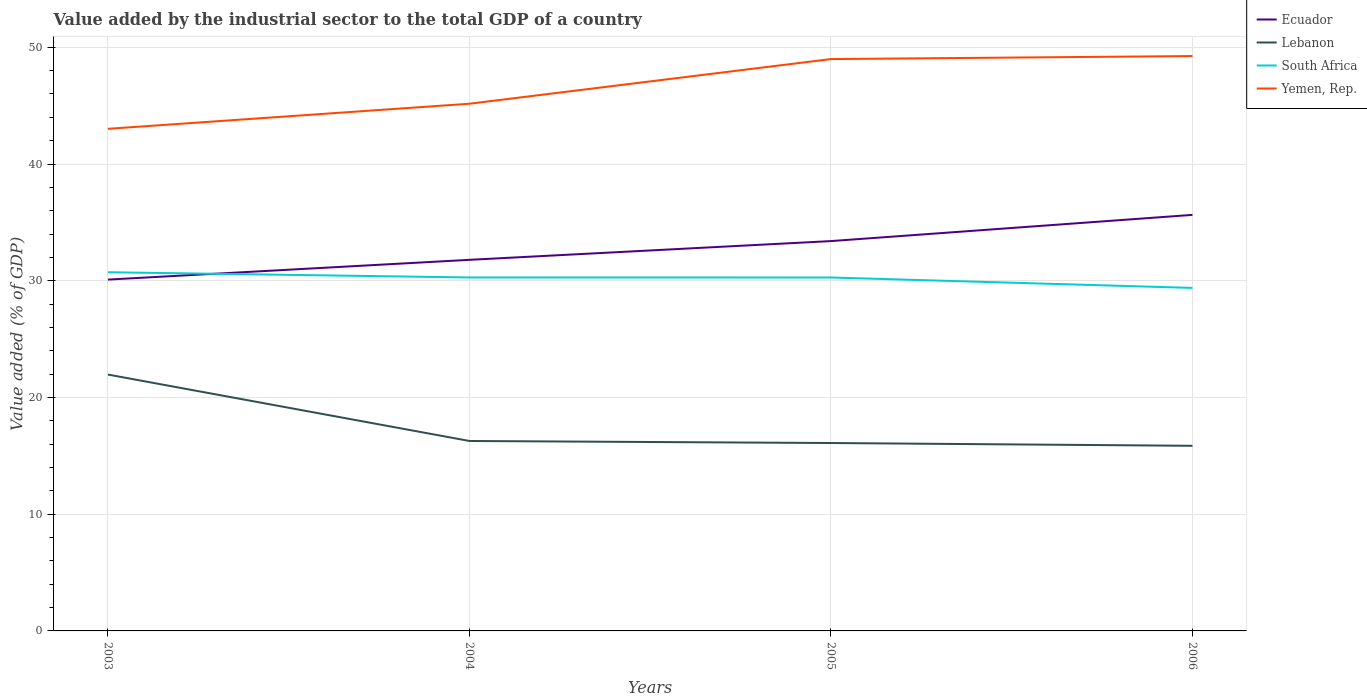How many different coloured lines are there?
Keep it short and to the point. 4. Is the number of lines equal to the number of legend labels?
Offer a very short reply. Yes. Across all years, what is the maximum value added by the industrial sector to the total GDP in Yemen, Rep.?
Ensure brevity in your answer.  43.01. What is the total value added by the industrial sector to the total GDP in Lebanon in the graph?
Your response must be concise. 5.69. What is the difference between the highest and the second highest value added by the industrial sector to the total GDP in Yemen, Rep.?
Provide a succinct answer. 6.23. What is the difference between the highest and the lowest value added by the industrial sector to the total GDP in South Africa?
Your answer should be very brief. 3. How many years are there in the graph?
Give a very brief answer. 4. What is the difference between two consecutive major ticks on the Y-axis?
Offer a very short reply. 10. Does the graph contain any zero values?
Give a very brief answer. No. How many legend labels are there?
Offer a very short reply. 4. What is the title of the graph?
Your answer should be compact. Value added by the industrial sector to the total GDP of a country. Does "World" appear as one of the legend labels in the graph?
Your response must be concise. No. What is the label or title of the X-axis?
Ensure brevity in your answer.  Years. What is the label or title of the Y-axis?
Provide a succinct answer. Value added (% of GDP). What is the Value added (% of GDP) of Ecuador in 2003?
Offer a terse response. 30.1. What is the Value added (% of GDP) of Lebanon in 2003?
Your answer should be compact. 21.96. What is the Value added (% of GDP) of South Africa in 2003?
Your answer should be very brief. 30.73. What is the Value added (% of GDP) of Yemen, Rep. in 2003?
Keep it short and to the point. 43.01. What is the Value added (% of GDP) in Ecuador in 2004?
Make the answer very short. 31.79. What is the Value added (% of GDP) of Lebanon in 2004?
Provide a short and direct response. 16.27. What is the Value added (% of GDP) of South Africa in 2004?
Your response must be concise. 30.28. What is the Value added (% of GDP) of Yemen, Rep. in 2004?
Provide a succinct answer. 45.16. What is the Value added (% of GDP) of Ecuador in 2005?
Ensure brevity in your answer.  33.4. What is the Value added (% of GDP) of Lebanon in 2005?
Ensure brevity in your answer.  16.1. What is the Value added (% of GDP) in South Africa in 2005?
Your answer should be very brief. 30.28. What is the Value added (% of GDP) in Yemen, Rep. in 2005?
Your answer should be compact. 48.99. What is the Value added (% of GDP) of Ecuador in 2006?
Give a very brief answer. 35.64. What is the Value added (% of GDP) of Lebanon in 2006?
Your response must be concise. 15.86. What is the Value added (% of GDP) of South Africa in 2006?
Your response must be concise. 29.39. What is the Value added (% of GDP) of Yemen, Rep. in 2006?
Provide a succinct answer. 49.25. Across all years, what is the maximum Value added (% of GDP) in Ecuador?
Make the answer very short. 35.64. Across all years, what is the maximum Value added (% of GDP) in Lebanon?
Offer a very short reply. 21.96. Across all years, what is the maximum Value added (% of GDP) of South Africa?
Make the answer very short. 30.73. Across all years, what is the maximum Value added (% of GDP) of Yemen, Rep.?
Your response must be concise. 49.25. Across all years, what is the minimum Value added (% of GDP) in Ecuador?
Provide a succinct answer. 30.1. Across all years, what is the minimum Value added (% of GDP) in Lebanon?
Provide a short and direct response. 15.86. Across all years, what is the minimum Value added (% of GDP) in South Africa?
Keep it short and to the point. 29.39. Across all years, what is the minimum Value added (% of GDP) of Yemen, Rep.?
Make the answer very short. 43.01. What is the total Value added (% of GDP) in Ecuador in the graph?
Provide a short and direct response. 130.93. What is the total Value added (% of GDP) of Lebanon in the graph?
Offer a very short reply. 70.19. What is the total Value added (% of GDP) of South Africa in the graph?
Make the answer very short. 120.67. What is the total Value added (% of GDP) in Yemen, Rep. in the graph?
Keep it short and to the point. 186.42. What is the difference between the Value added (% of GDP) in Ecuador in 2003 and that in 2004?
Your answer should be very brief. -1.69. What is the difference between the Value added (% of GDP) of Lebanon in 2003 and that in 2004?
Ensure brevity in your answer.  5.69. What is the difference between the Value added (% of GDP) of South Africa in 2003 and that in 2004?
Provide a short and direct response. 0.45. What is the difference between the Value added (% of GDP) of Yemen, Rep. in 2003 and that in 2004?
Your answer should be very brief. -2.15. What is the difference between the Value added (% of GDP) in Ecuador in 2003 and that in 2005?
Your response must be concise. -3.3. What is the difference between the Value added (% of GDP) in Lebanon in 2003 and that in 2005?
Ensure brevity in your answer.  5.87. What is the difference between the Value added (% of GDP) in South Africa in 2003 and that in 2005?
Your response must be concise. 0.45. What is the difference between the Value added (% of GDP) in Yemen, Rep. in 2003 and that in 2005?
Your answer should be very brief. -5.97. What is the difference between the Value added (% of GDP) of Ecuador in 2003 and that in 2006?
Your response must be concise. -5.54. What is the difference between the Value added (% of GDP) in Lebanon in 2003 and that in 2006?
Offer a very short reply. 6.1. What is the difference between the Value added (% of GDP) in South Africa in 2003 and that in 2006?
Make the answer very short. 1.34. What is the difference between the Value added (% of GDP) in Yemen, Rep. in 2003 and that in 2006?
Your answer should be compact. -6.23. What is the difference between the Value added (% of GDP) of Ecuador in 2004 and that in 2005?
Your response must be concise. -1.61. What is the difference between the Value added (% of GDP) of Lebanon in 2004 and that in 2005?
Offer a terse response. 0.17. What is the difference between the Value added (% of GDP) of South Africa in 2004 and that in 2005?
Keep it short and to the point. 0. What is the difference between the Value added (% of GDP) in Yemen, Rep. in 2004 and that in 2005?
Offer a terse response. -3.83. What is the difference between the Value added (% of GDP) of Ecuador in 2004 and that in 2006?
Provide a succinct answer. -3.85. What is the difference between the Value added (% of GDP) in Lebanon in 2004 and that in 2006?
Offer a terse response. 0.41. What is the difference between the Value added (% of GDP) of South Africa in 2004 and that in 2006?
Keep it short and to the point. 0.89. What is the difference between the Value added (% of GDP) in Yemen, Rep. in 2004 and that in 2006?
Make the answer very short. -4.08. What is the difference between the Value added (% of GDP) in Ecuador in 2005 and that in 2006?
Offer a very short reply. -2.25. What is the difference between the Value added (% of GDP) in Lebanon in 2005 and that in 2006?
Provide a short and direct response. 0.24. What is the difference between the Value added (% of GDP) in South Africa in 2005 and that in 2006?
Make the answer very short. 0.89. What is the difference between the Value added (% of GDP) in Yemen, Rep. in 2005 and that in 2006?
Provide a short and direct response. -0.26. What is the difference between the Value added (% of GDP) of Ecuador in 2003 and the Value added (% of GDP) of Lebanon in 2004?
Give a very brief answer. 13.83. What is the difference between the Value added (% of GDP) of Ecuador in 2003 and the Value added (% of GDP) of South Africa in 2004?
Keep it short and to the point. -0.18. What is the difference between the Value added (% of GDP) of Ecuador in 2003 and the Value added (% of GDP) of Yemen, Rep. in 2004?
Keep it short and to the point. -15.07. What is the difference between the Value added (% of GDP) in Lebanon in 2003 and the Value added (% of GDP) in South Africa in 2004?
Offer a terse response. -8.32. What is the difference between the Value added (% of GDP) of Lebanon in 2003 and the Value added (% of GDP) of Yemen, Rep. in 2004?
Ensure brevity in your answer.  -23.2. What is the difference between the Value added (% of GDP) in South Africa in 2003 and the Value added (% of GDP) in Yemen, Rep. in 2004?
Provide a succinct answer. -14.44. What is the difference between the Value added (% of GDP) of Ecuador in 2003 and the Value added (% of GDP) of Lebanon in 2005?
Keep it short and to the point. 14. What is the difference between the Value added (% of GDP) of Ecuador in 2003 and the Value added (% of GDP) of South Africa in 2005?
Offer a terse response. -0.18. What is the difference between the Value added (% of GDP) in Ecuador in 2003 and the Value added (% of GDP) in Yemen, Rep. in 2005?
Your response must be concise. -18.89. What is the difference between the Value added (% of GDP) in Lebanon in 2003 and the Value added (% of GDP) in South Africa in 2005?
Offer a very short reply. -8.32. What is the difference between the Value added (% of GDP) in Lebanon in 2003 and the Value added (% of GDP) in Yemen, Rep. in 2005?
Offer a very short reply. -27.03. What is the difference between the Value added (% of GDP) of South Africa in 2003 and the Value added (% of GDP) of Yemen, Rep. in 2005?
Keep it short and to the point. -18.26. What is the difference between the Value added (% of GDP) in Ecuador in 2003 and the Value added (% of GDP) in Lebanon in 2006?
Provide a succinct answer. 14.24. What is the difference between the Value added (% of GDP) in Ecuador in 2003 and the Value added (% of GDP) in South Africa in 2006?
Your answer should be very brief. 0.71. What is the difference between the Value added (% of GDP) of Ecuador in 2003 and the Value added (% of GDP) of Yemen, Rep. in 2006?
Your answer should be compact. -19.15. What is the difference between the Value added (% of GDP) in Lebanon in 2003 and the Value added (% of GDP) in South Africa in 2006?
Give a very brief answer. -7.42. What is the difference between the Value added (% of GDP) of Lebanon in 2003 and the Value added (% of GDP) of Yemen, Rep. in 2006?
Provide a short and direct response. -27.28. What is the difference between the Value added (% of GDP) of South Africa in 2003 and the Value added (% of GDP) of Yemen, Rep. in 2006?
Keep it short and to the point. -18.52. What is the difference between the Value added (% of GDP) in Ecuador in 2004 and the Value added (% of GDP) in Lebanon in 2005?
Your answer should be very brief. 15.69. What is the difference between the Value added (% of GDP) in Ecuador in 2004 and the Value added (% of GDP) in South Africa in 2005?
Make the answer very short. 1.51. What is the difference between the Value added (% of GDP) of Ecuador in 2004 and the Value added (% of GDP) of Yemen, Rep. in 2005?
Your answer should be compact. -17.2. What is the difference between the Value added (% of GDP) of Lebanon in 2004 and the Value added (% of GDP) of South Africa in 2005?
Your answer should be compact. -14.01. What is the difference between the Value added (% of GDP) in Lebanon in 2004 and the Value added (% of GDP) in Yemen, Rep. in 2005?
Offer a terse response. -32.72. What is the difference between the Value added (% of GDP) in South Africa in 2004 and the Value added (% of GDP) in Yemen, Rep. in 2005?
Offer a very short reply. -18.71. What is the difference between the Value added (% of GDP) of Ecuador in 2004 and the Value added (% of GDP) of Lebanon in 2006?
Provide a succinct answer. 15.93. What is the difference between the Value added (% of GDP) of Ecuador in 2004 and the Value added (% of GDP) of South Africa in 2006?
Your answer should be compact. 2.41. What is the difference between the Value added (% of GDP) of Ecuador in 2004 and the Value added (% of GDP) of Yemen, Rep. in 2006?
Your response must be concise. -17.46. What is the difference between the Value added (% of GDP) in Lebanon in 2004 and the Value added (% of GDP) in South Africa in 2006?
Give a very brief answer. -13.11. What is the difference between the Value added (% of GDP) of Lebanon in 2004 and the Value added (% of GDP) of Yemen, Rep. in 2006?
Ensure brevity in your answer.  -32.98. What is the difference between the Value added (% of GDP) in South Africa in 2004 and the Value added (% of GDP) in Yemen, Rep. in 2006?
Ensure brevity in your answer.  -18.97. What is the difference between the Value added (% of GDP) in Ecuador in 2005 and the Value added (% of GDP) in Lebanon in 2006?
Keep it short and to the point. 17.54. What is the difference between the Value added (% of GDP) of Ecuador in 2005 and the Value added (% of GDP) of South Africa in 2006?
Offer a terse response. 4.01. What is the difference between the Value added (% of GDP) of Ecuador in 2005 and the Value added (% of GDP) of Yemen, Rep. in 2006?
Your response must be concise. -15.85. What is the difference between the Value added (% of GDP) of Lebanon in 2005 and the Value added (% of GDP) of South Africa in 2006?
Provide a short and direct response. -13.29. What is the difference between the Value added (% of GDP) in Lebanon in 2005 and the Value added (% of GDP) in Yemen, Rep. in 2006?
Make the answer very short. -33.15. What is the difference between the Value added (% of GDP) of South Africa in 2005 and the Value added (% of GDP) of Yemen, Rep. in 2006?
Your response must be concise. -18.97. What is the average Value added (% of GDP) in Ecuador per year?
Offer a very short reply. 32.73. What is the average Value added (% of GDP) in Lebanon per year?
Offer a terse response. 17.55. What is the average Value added (% of GDP) of South Africa per year?
Offer a terse response. 30.17. What is the average Value added (% of GDP) of Yemen, Rep. per year?
Provide a succinct answer. 46.6. In the year 2003, what is the difference between the Value added (% of GDP) of Ecuador and Value added (% of GDP) of Lebanon?
Offer a very short reply. 8.14. In the year 2003, what is the difference between the Value added (% of GDP) in Ecuador and Value added (% of GDP) in South Africa?
Offer a very short reply. -0.63. In the year 2003, what is the difference between the Value added (% of GDP) in Ecuador and Value added (% of GDP) in Yemen, Rep.?
Your answer should be very brief. -12.92. In the year 2003, what is the difference between the Value added (% of GDP) of Lebanon and Value added (% of GDP) of South Africa?
Your answer should be very brief. -8.77. In the year 2003, what is the difference between the Value added (% of GDP) in Lebanon and Value added (% of GDP) in Yemen, Rep.?
Give a very brief answer. -21.05. In the year 2003, what is the difference between the Value added (% of GDP) in South Africa and Value added (% of GDP) in Yemen, Rep.?
Ensure brevity in your answer.  -12.29. In the year 2004, what is the difference between the Value added (% of GDP) in Ecuador and Value added (% of GDP) in Lebanon?
Provide a succinct answer. 15.52. In the year 2004, what is the difference between the Value added (% of GDP) in Ecuador and Value added (% of GDP) in South Africa?
Provide a succinct answer. 1.51. In the year 2004, what is the difference between the Value added (% of GDP) in Ecuador and Value added (% of GDP) in Yemen, Rep.?
Your response must be concise. -13.37. In the year 2004, what is the difference between the Value added (% of GDP) in Lebanon and Value added (% of GDP) in South Africa?
Your answer should be very brief. -14.01. In the year 2004, what is the difference between the Value added (% of GDP) of Lebanon and Value added (% of GDP) of Yemen, Rep.?
Keep it short and to the point. -28.89. In the year 2004, what is the difference between the Value added (% of GDP) in South Africa and Value added (% of GDP) in Yemen, Rep.?
Keep it short and to the point. -14.88. In the year 2005, what is the difference between the Value added (% of GDP) in Ecuador and Value added (% of GDP) in Lebanon?
Offer a terse response. 17.3. In the year 2005, what is the difference between the Value added (% of GDP) in Ecuador and Value added (% of GDP) in South Africa?
Your answer should be compact. 3.12. In the year 2005, what is the difference between the Value added (% of GDP) in Ecuador and Value added (% of GDP) in Yemen, Rep.?
Keep it short and to the point. -15.59. In the year 2005, what is the difference between the Value added (% of GDP) in Lebanon and Value added (% of GDP) in South Africa?
Give a very brief answer. -14.18. In the year 2005, what is the difference between the Value added (% of GDP) of Lebanon and Value added (% of GDP) of Yemen, Rep.?
Your answer should be compact. -32.89. In the year 2005, what is the difference between the Value added (% of GDP) of South Africa and Value added (% of GDP) of Yemen, Rep.?
Offer a terse response. -18.71. In the year 2006, what is the difference between the Value added (% of GDP) in Ecuador and Value added (% of GDP) in Lebanon?
Offer a terse response. 19.78. In the year 2006, what is the difference between the Value added (% of GDP) in Ecuador and Value added (% of GDP) in South Africa?
Keep it short and to the point. 6.26. In the year 2006, what is the difference between the Value added (% of GDP) of Ecuador and Value added (% of GDP) of Yemen, Rep.?
Your answer should be very brief. -13.61. In the year 2006, what is the difference between the Value added (% of GDP) in Lebanon and Value added (% of GDP) in South Africa?
Make the answer very short. -13.53. In the year 2006, what is the difference between the Value added (% of GDP) in Lebanon and Value added (% of GDP) in Yemen, Rep.?
Offer a terse response. -33.39. In the year 2006, what is the difference between the Value added (% of GDP) in South Africa and Value added (% of GDP) in Yemen, Rep.?
Ensure brevity in your answer.  -19.86. What is the ratio of the Value added (% of GDP) in Ecuador in 2003 to that in 2004?
Offer a terse response. 0.95. What is the ratio of the Value added (% of GDP) of Lebanon in 2003 to that in 2004?
Offer a very short reply. 1.35. What is the ratio of the Value added (% of GDP) of South Africa in 2003 to that in 2004?
Ensure brevity in your answer.  1.01. What is the ratio of the Value added (% of GDP) in Yemen, Rep. in 2003 to that in 2004?
Your answer should be compact. 0.95. What is the ratio of the Value added (% of GDP) of Ecuador in 2003 to that in 2005?
Keep it short and to the point. 0.9. What is the ratio of the Value added (% of GDP) in Lebanon in 2003 to that in 2005?
Make the answer very short. 1.36. What is the ratio of the Value added (% of GDP) in South Africa in 2003 to that in 2005?
Your answer should be compact. 1.01. What is the ratio of the Value added (% of GDP) of Yemen, Rep. in 2003 to that in 2005?
Offer a terse response. 0.88. What is the ratio of the Value added (% of GDP) of Ecuador in 2003 to that in 2006?
Offer a terse response. 0.84. What is the ratio of the Value added (% of GDP) of Lebanon in 2003 to that in 2006?
Give a very brief answer. 1.38. What is the ratio of the Value added (% of GDP) in South Africa in 2003 to that in 2006?
Ensure brevity in your answer.  1.05. What is the ratio of the Value added (% of GDP) in Yemen, Rep. in 2003 to that in 2006?
Your answer should be very brief. 0.87. What is the ratio of the Value added (% of GDP) in Ecuador in 2004 to that in 2005?
Your answer should be very brief. 0.95. What is the ratio of the Value added (% of GDP) in Lebanon in 2004 to that in 2005?
Provide a succinct answer. 1.01. What is the ratio of the Value added (% of GDP) of South Africa in 2004 to that in 2005?
Make the answer very short. 1. What is the ratio of the Value added (% of GDP) of Yemen, Rep. in 2004 to that in 2005?
Provide a succinct answer. 0.92. What is the ratio of the Value added (% of GDP) in Ecuador in 2004 to that in 2006?
Give a very brief answer. 0.89. What is the ratio of the Value added (% of GDP) in Lebanon in 2004 to that in 2006?
Your answer should be very brief. 1.03. What is the ratio of the Value added (% of GDP) of South Africa in 2004 to that in 2006?
Provide a short and direct response. 1.03. What is the ratio of the Value added (% of GDP) of Yemen, Rep. in 2004 to that in 2006?
Ensure brevity in your answer.  0.92. What is the ratio of the Value added (% of GDP) of Ecuador in 2005 to that in 2006?
Your answer should be very brief. 0.94. What is the ratio of the Value added (% of GDP) of South Africa in 2005 to that in 2006?
Provide a short and direct response. 1.03. What is the ratio of the Value added (% of GDP) in Yemen, Rep. in 2005 to that in 2006?
Make the answer very short. 0.99. What is the difference between the highest and the second highest Value added (% of GDP) of Ecuador?
Your response must be concise. 2.25. What is the difference between the highest and the second highest Value added (% of GDP) of Lebanon?
Offer a very short reply. 5.69. What is the difference between the highest and the second highest Value added (% of GDP) in South Africa?
Offer a terse response. 0.45. What is the difference between the highest and the second highest Value added (% of GDP) of Yemen, Rep.?
Provide a short and direct response. 0.26. What is the difference between the highest and the lowest Value added (% of GDP) in Ecuador?
Provide a short and direct response. 5.54. What is the difference between the highest and the lowest Value added (% of GDP) of Lebanon?
Provide a short and direct response. 6.1. What is the difference between the highest and the lowest Value added (% of GDP) in South Africa?
Your response must be concise. 1.34. What is the difference between the highest and the lowest Value added (% of GDP) in Yemen, Rep.?
Keep it short and to the point. 6.23. 